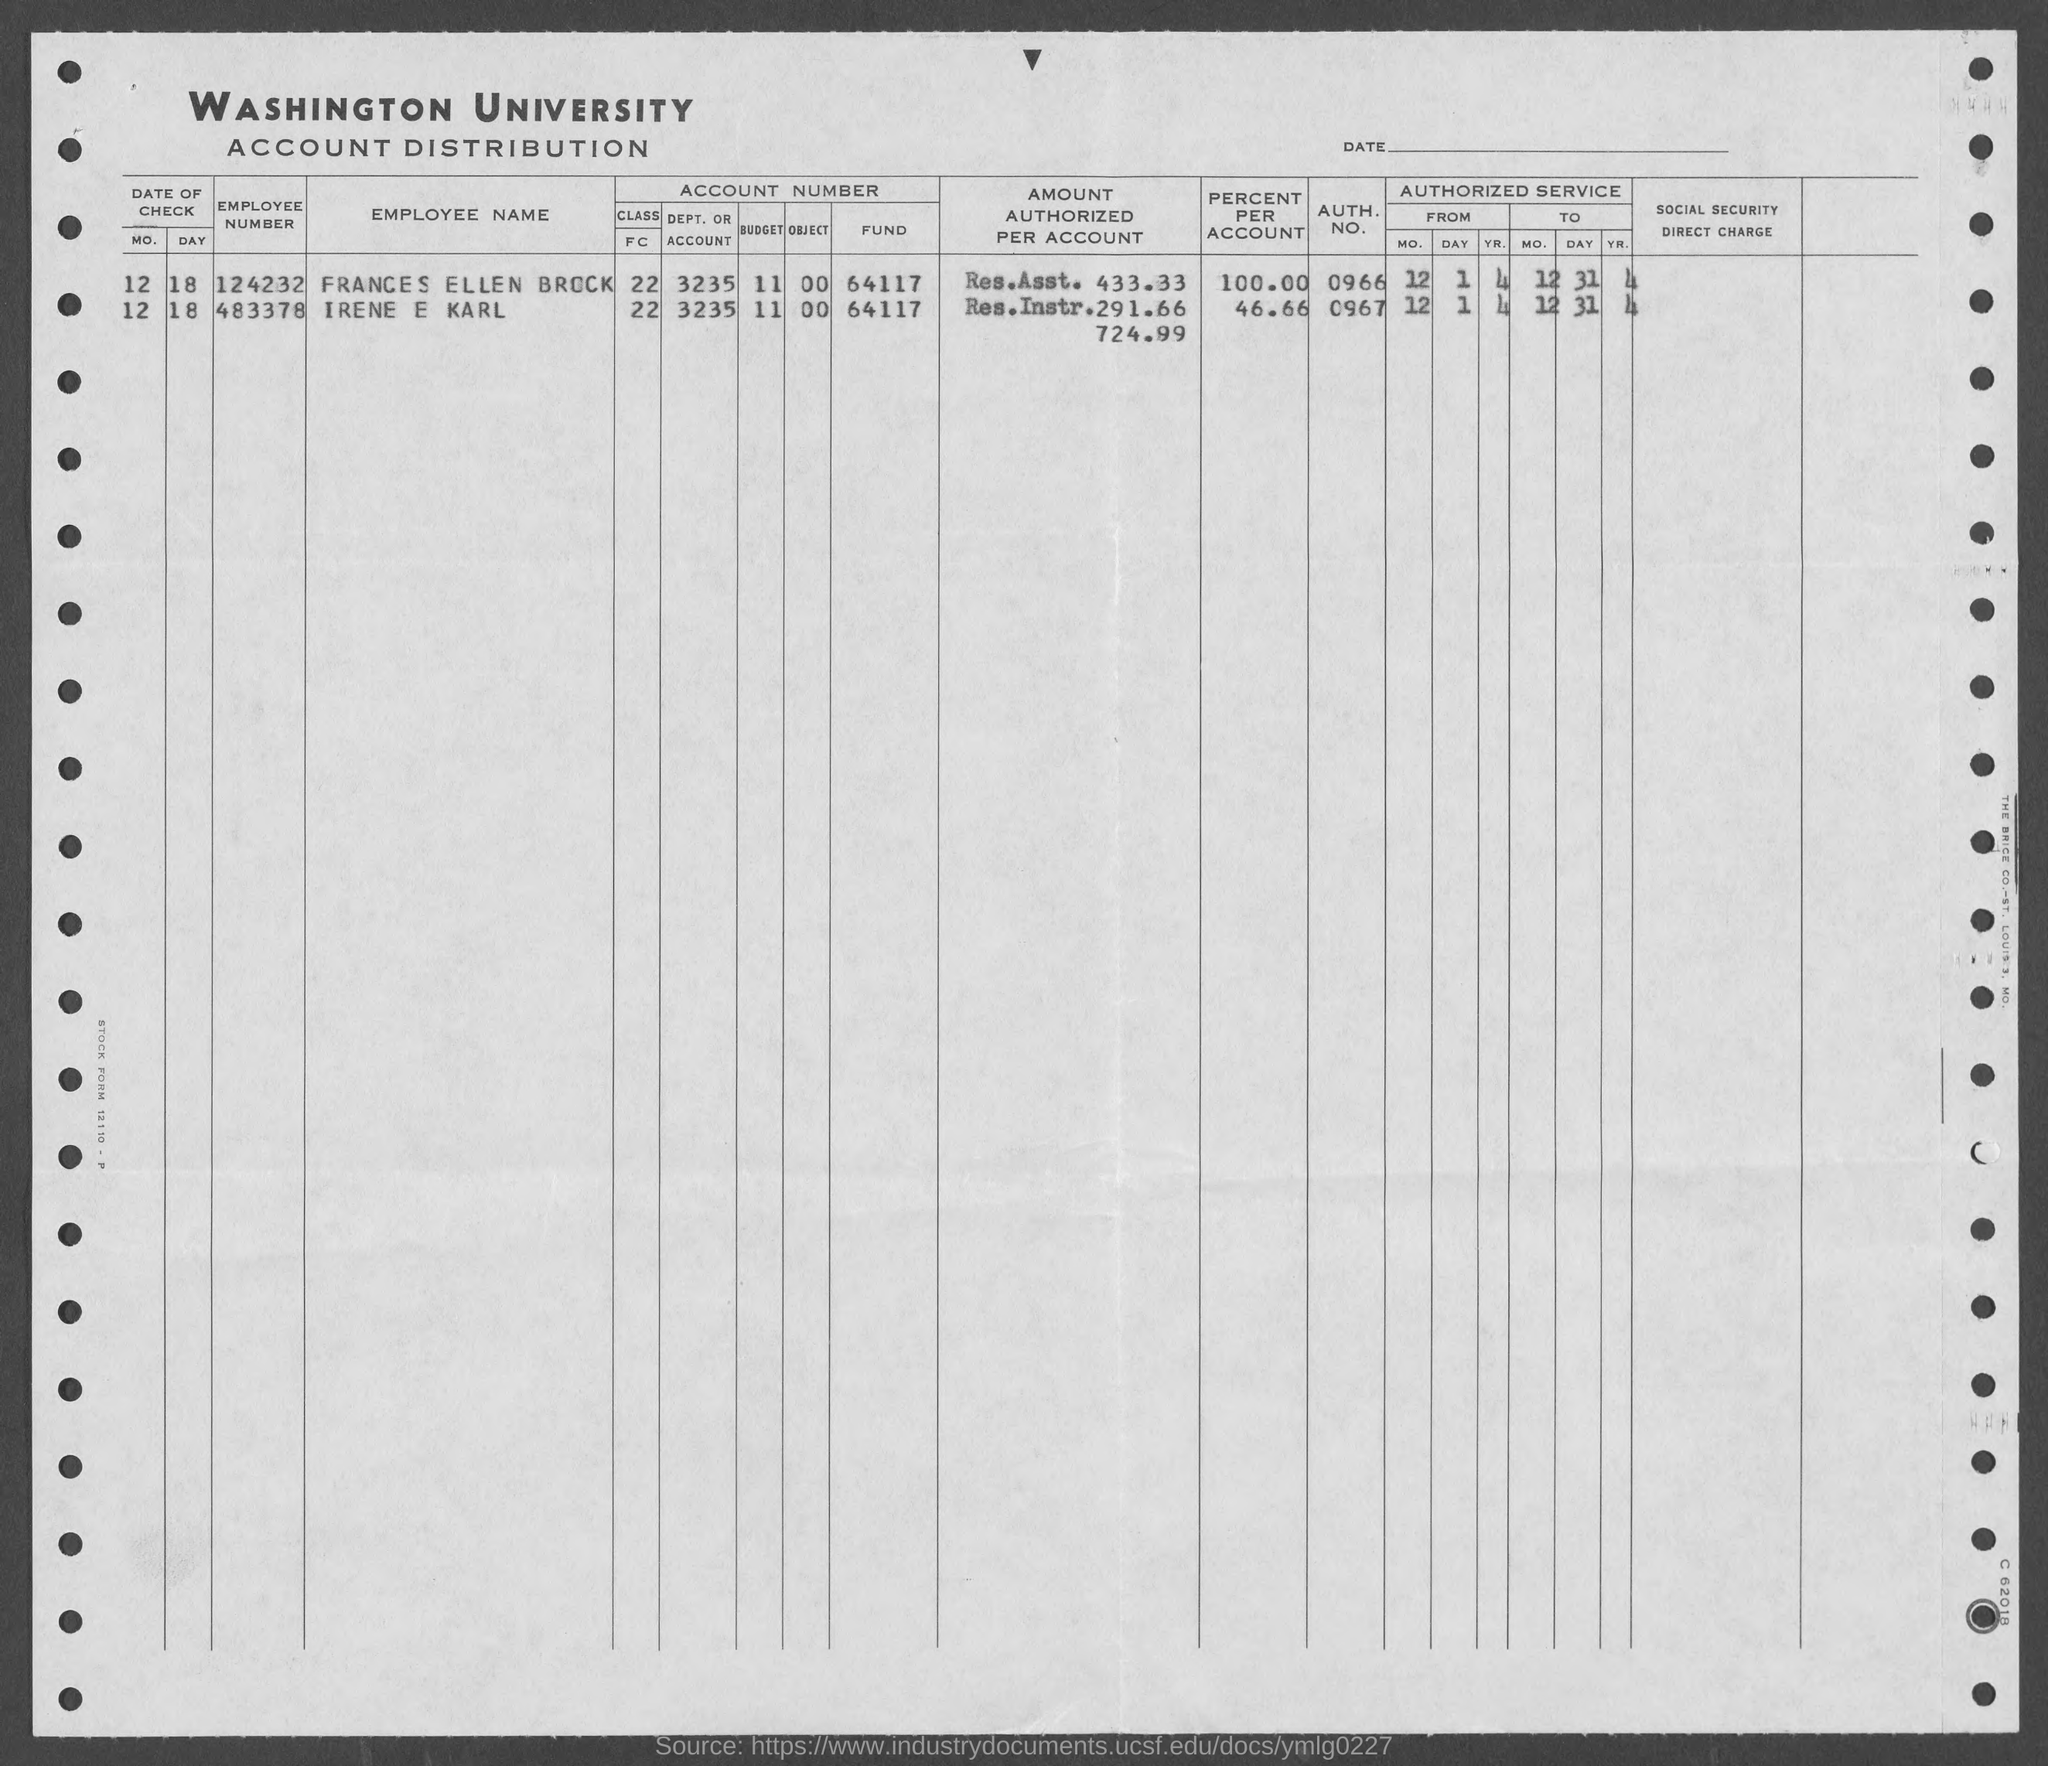Give some essential details in this illustration. The employee number of Irene E Karl is 483378. The second title in the document is "Account Distribution. Frances Ellen Brock is the employee number 124232. The document's first title is "Washington University. 